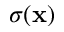<formula> <loc_0><loc_0><loc_500><loc_500>\sigma ( \mathbf x )</formula> 